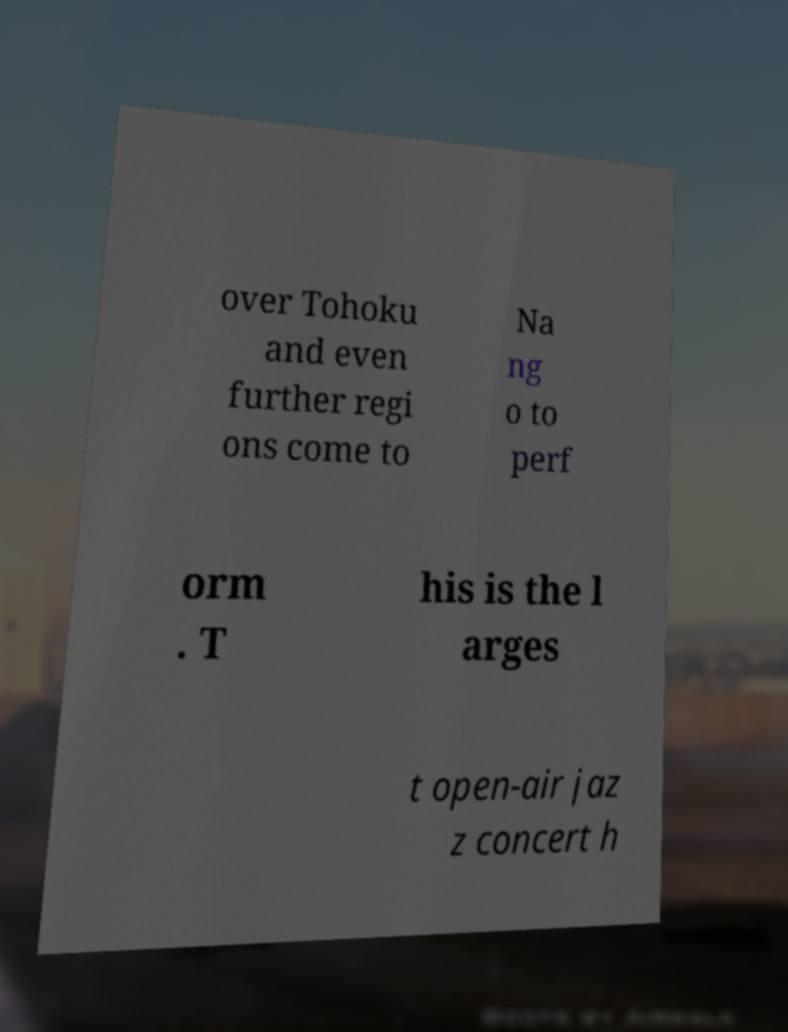Please identify and transcribe the text found in this image. over Tohoku and even further regi ons come to Na ng o to perf orm . T his is the l arges t open-air jaz z concert h 